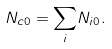Convert formula to latex. <formula><loc_0><loc_0><loc_500><loc_500>N _ { c 0 } = { \sum _ { i } } N _ { i 0 } .</formula> 